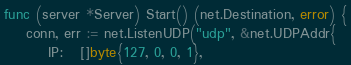<code> <loc_0><loc_0><loc_500><loc_500><_Go_>func (server *Server) Start() (net.Destination, error) {
	conn, err := net.ListenUDP("udp", &net.UDPAddr{
		IP:   []byte{127, 0, 0, 1},</code> 